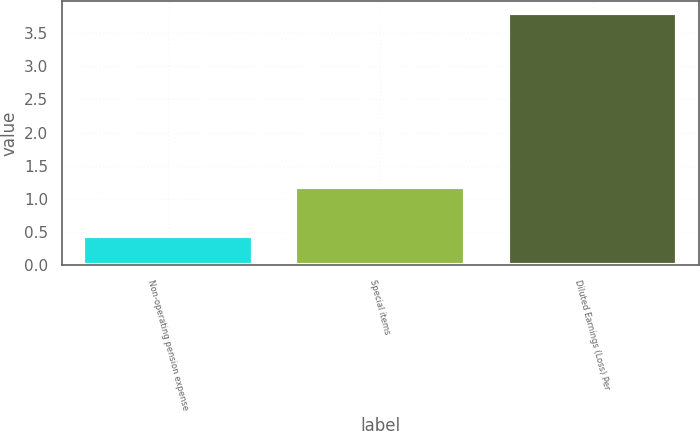Convert chart to OTSL. <chart><loc_0><loc_0><loc_500><loc_500><bar_chart><fcel>Non-operating pension expense<fcel>Special items<fcel>Diluted Earnings (Loss) Per<nl><fcel>0.44<fcel>1.18<fcel>3.8<nl></chart> 